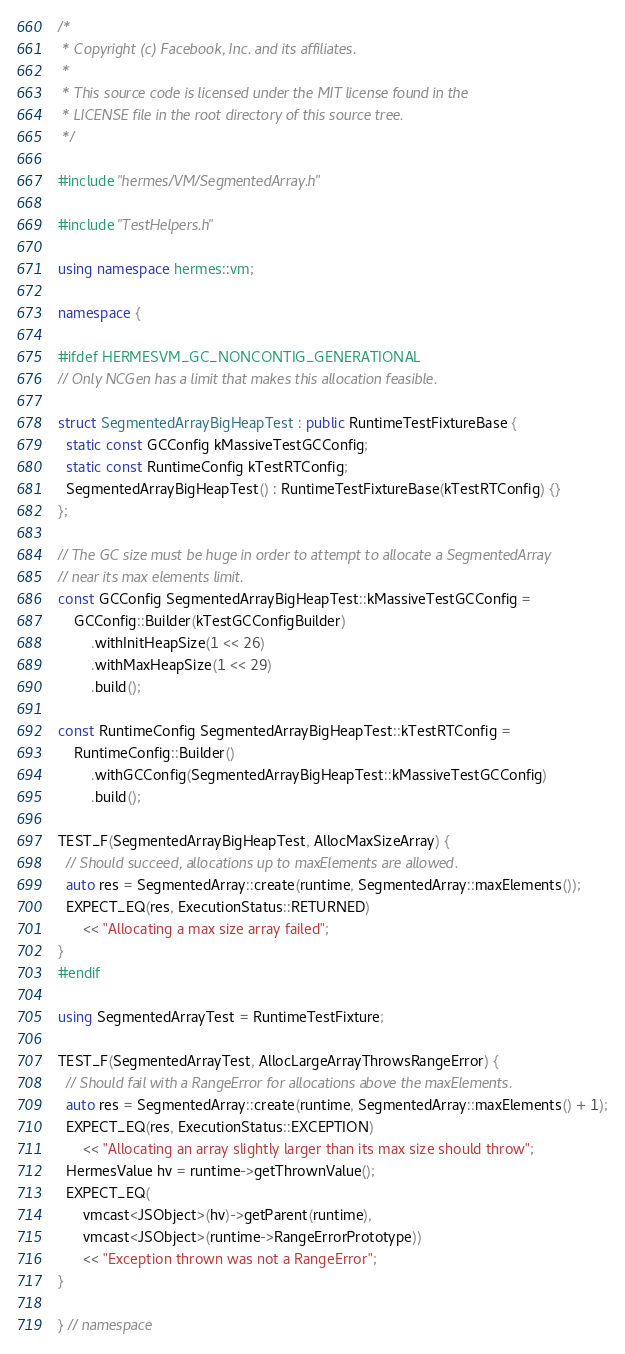Convert code to text. <code><loc_0><loc_0><loc_500><loc_500><_C++_>/*
 * Copyright (c) Facebook, Inc. and its affiliates.
 *
 * This source code is licensed under the MIT license found in the
 * LICENSE file in the root directory of this source tree.
 */

#include "hermes/VM/SegmentedArray.h"

#include "TestHelpers.h"

using namespace hermes::vm;

namespace {

#ifdef HERMESVM_GC_NONCONTIG_GENERATIONAL
// Only NCGen has a limit that makes this allocation feasible.

struct SegmentedArrayBigHeapTest : public RuntimeTestFixtureBase {
  static const GCConfig kMassiveTestGCConfig;
  static const RuntimeConfig kTestRTConfig;
  SegmentedArrayBigHeapTest() : RuntimeTestFixtureBase(kTestRTConfig) {}
};

// The GC size must be huge in order to attempt to allocate a SegmentedArray
// near its max elements limit.
const GCConfig SegmentedArrayBigHeapTest::kMassiveTestGCConfig =
    GCConfig::Builder(kTestGCConfigBuilder)
        .withInitHeapSize(1 << 26)
        .withMaxHeapSize(1 << 29)
        .build();

const RuntimeConfig SegmentedArrayBigHeapTest::kTestRTConfig =
    RuntimeConfig::Builder()
        .withGCConfig(SegmentedArrayBigHeapTest::kMassiveTestGCConfig)
        .build();

TEST_F(SegmentedArrayBigHeapTest, AllocMaxSizeArray) {
  // Should succeed, allocations up to maxElements are allowed.
  auto res = SegmentedArray::create(runtime, SegmentedArray::maxElements());
  EXPECT_EQ(res, ExecutionStatus::RETURNED)
      << "Allocating a max size array failed";
}
#endif

using SegmentedArrayTest = RuntimeTestFixture;

TEST_F(SegmentedArrayTest, AllocLargeArrayThrowsRangeError) {
  // Should fail with a RangeError for allocations above the maxElements.
  auto res = SegmentedArray::create(runtime, SegmentedArray::maxElements() + 1);
  EXPECT_EQ(res, ExecutionStatus::EXCEPTION)
      << "Allocating an array slightly larger than its max size should throw";
  HermesValue hv = runtime->getThrownValue();
  EXPECT_EQ(
      vmcast<JSObject>(hv)->getParent(runtime),
      vmcast<JSObject>(runtime->RangeErrorPrototype))
      << "Exception thrown was not a RangeError";
}

} // namespace
</code> 